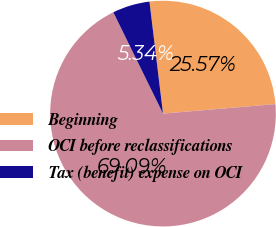Convert chart to OTSL. <chart><loc_0><loc_0><loc_500><loc_500><pie_chart><fcel>Beginning<fcel>OCI before reclassifications<fcel>Tax (benefit) expense on OCI<nl><fcel>25.57%<fcel>69.08%<fcel>5.34%<nl></chart> 